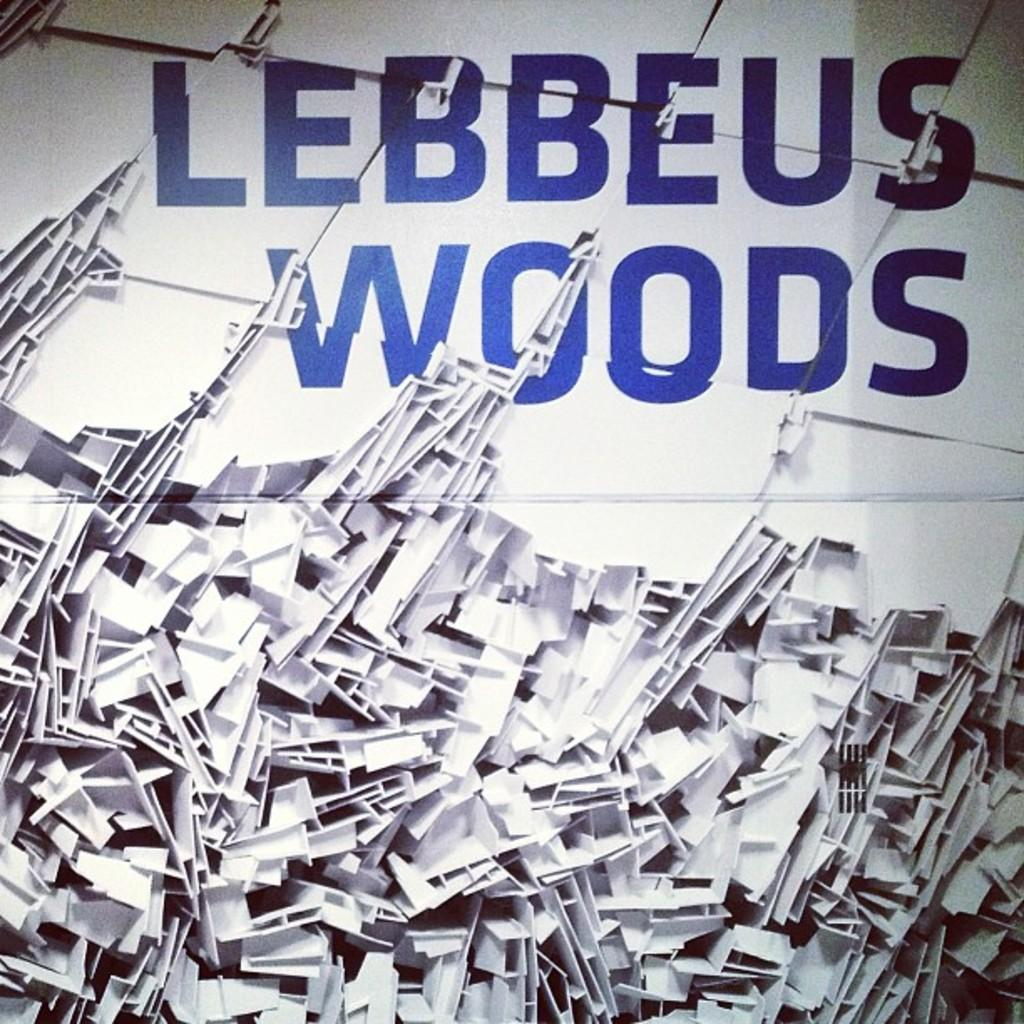Provide a one-sentence caption for the provided image. A pile of fragmented white plastic underneath large blue words reading Lebbeus Woods. 